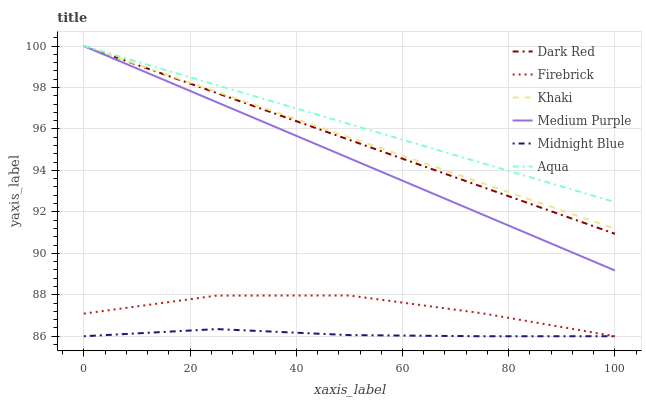Does Midnight Blue have the minimum area under the curve?
Answer yes or no. Yes. Does Aqua have the maximum area under the curve?
Answer yes or no. Yes. Does Dark Red have the minimum area under the curve?
Answer yes or no. No. Does Dark Red have the maximum area under the curve?
Answer yes or no. No. Is Aqua the smoothest?
Answer yes or no. Yes. Is Firebrick the roughest?
Answer yes or no. Yes. Is Midnight Blue the smoothest?
Answer yes or no. No. Is Midnight Blue the roughest?
Answer yes or no. No. Does Midnight Blue have the lowest value?
Answer yes or no. Yes. Does Dark Red have the lowest value?
Answer yes or no. No. Does Medium Purple have the highest value?
Answer yes or no. Yes. Does Midnight Blue have the highest value?
Answer yes or no. No. Is Firebrick less than Aqua?
Answer yes or no. Yes. Is Dark Red greater than Firebrick?
Answer yes or no. Yes. Does Medium Purple intersect Aqua?
Answer yes or no. Yes. Is Medium Purple less than Aqua?
Answer yes or no. No. Is Medium Purple greater than Aqua?
Answer yes or no. No. Does Firebrick intersect Aqua?
Answer yes or no. No. 